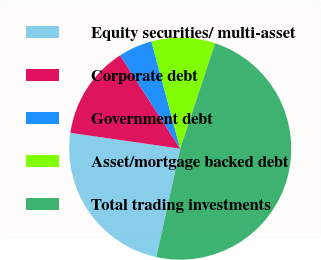Convert chart to OTSL. <chart><loc_0><loc_0><loc_500><loc_500><pie_chart><fcel>Equity securities/ multi-asset<fcel>Corporate debt<fcel>Government debt<fcel>Asset/mortgage backed debt<fcel>Total trading investments<nl><fcel>23.82%<fcel>13.62%<fcel>4.93%<fcel>9.27%<fcel>48.37%<nl></chart> 